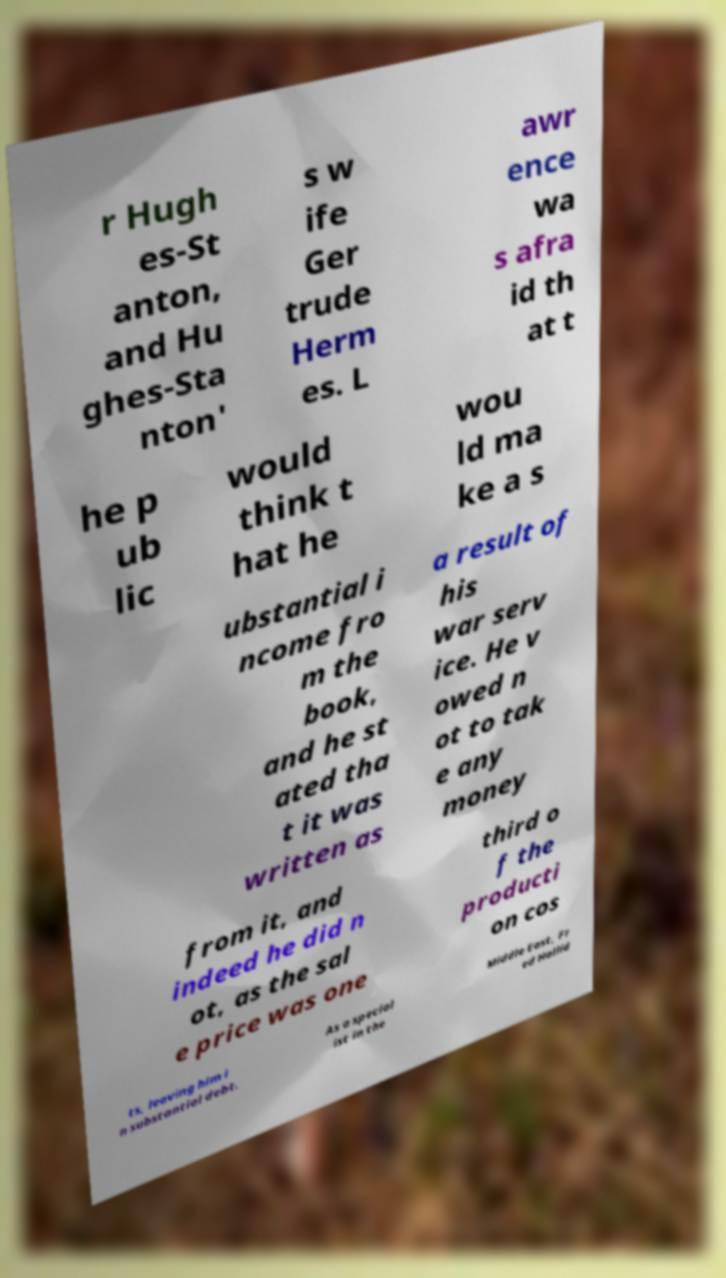Can you read and provide the text displayed in the image?This photo seems to have some interesting text. Can you extract and type it out for me? r Hugh es-St anton, and Hu ghes-Sta nton' s w ife Ger trude Herm es. L awr ence wa s afra id th at t he p ub lic would think t hat he wou ld ma ke a s ubstantial i ncome fro m the book, and he st ated tha t it was written as a result of his war serv ice. He v owed n ot to tak e any money from it, and indeed he did n ot, as the sal e price was one third o f the producti on cos ts, leaving him i n substantial debt. As a special ist in the Middle East, Fr ed Hallid 